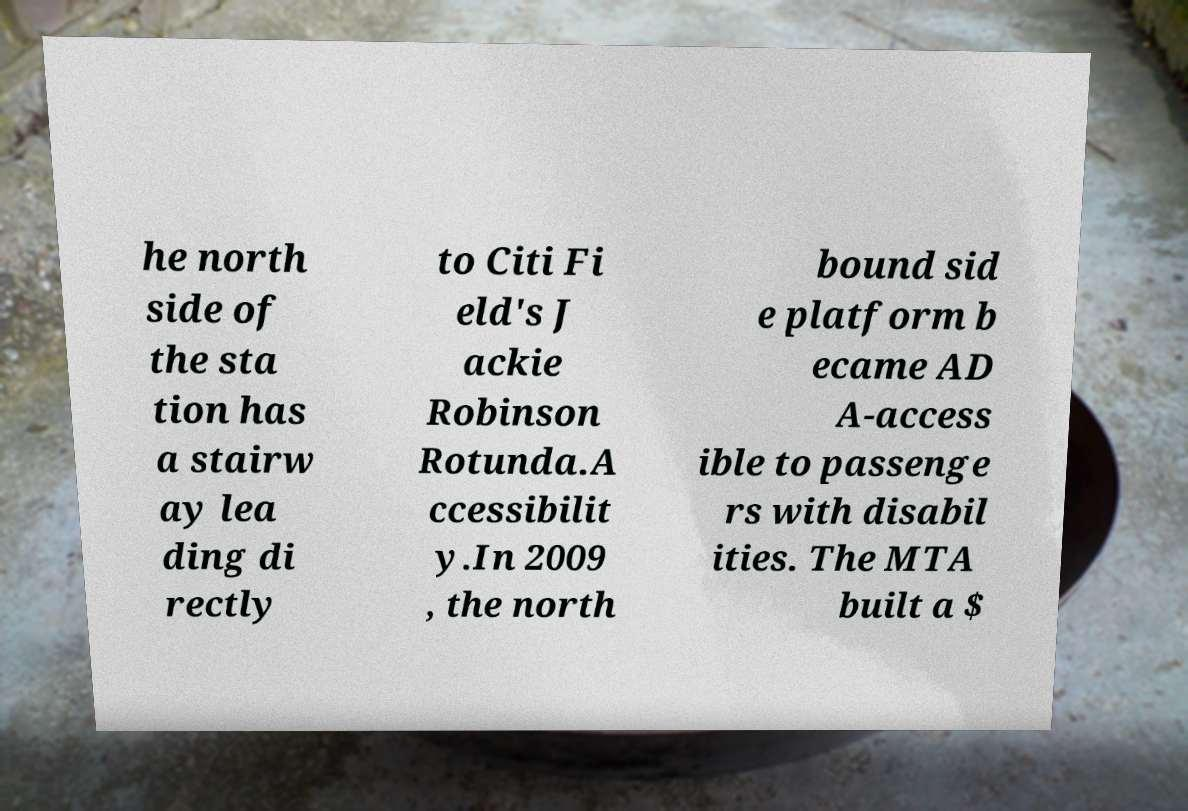There's text embedded in this image that I need extracted. Can you transcribe it verbatim? he north side of the sta tion has a stairw ay lea ding di rectly to Citi Fi eld's J ackie Robinson Rotunda.A ccessibilit y.In 2009 , the north bound sid e platform b ecame AD A-access ible to passenge rs with disabil ities. The MTA built a $ 